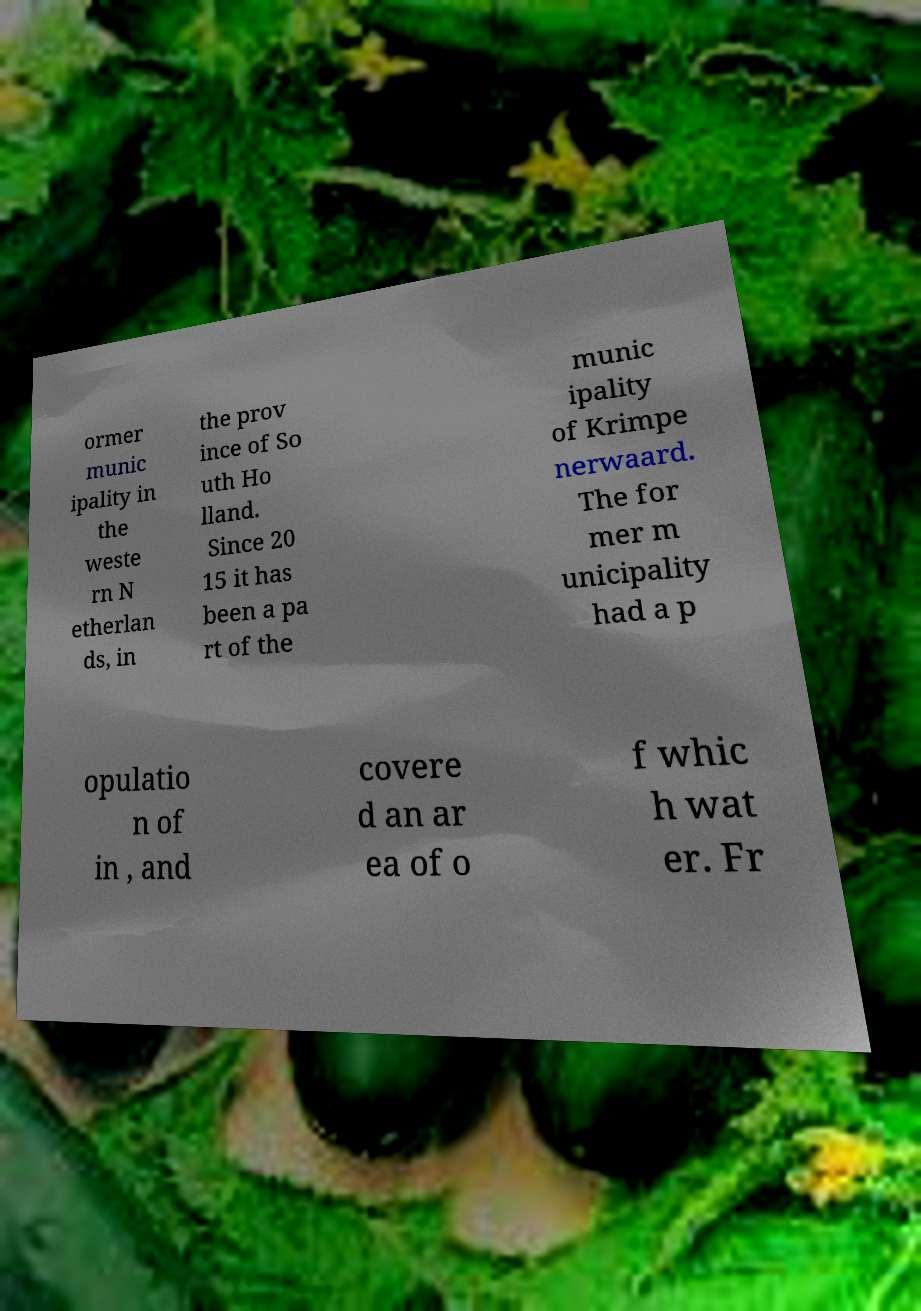Could you assist in decoding the text presented in this image and type it out clearly? ormer munic ipality in the weste rn N etherlan ds, in the prov ince of So uth Ho lland. Since 20 15 it has been a pa rt of the munic ipality of Krimpe nerwaard. The for mer m unicipality had a p opulatio n of in , and covere d an ar ea of o f whic h wat er. Fr 